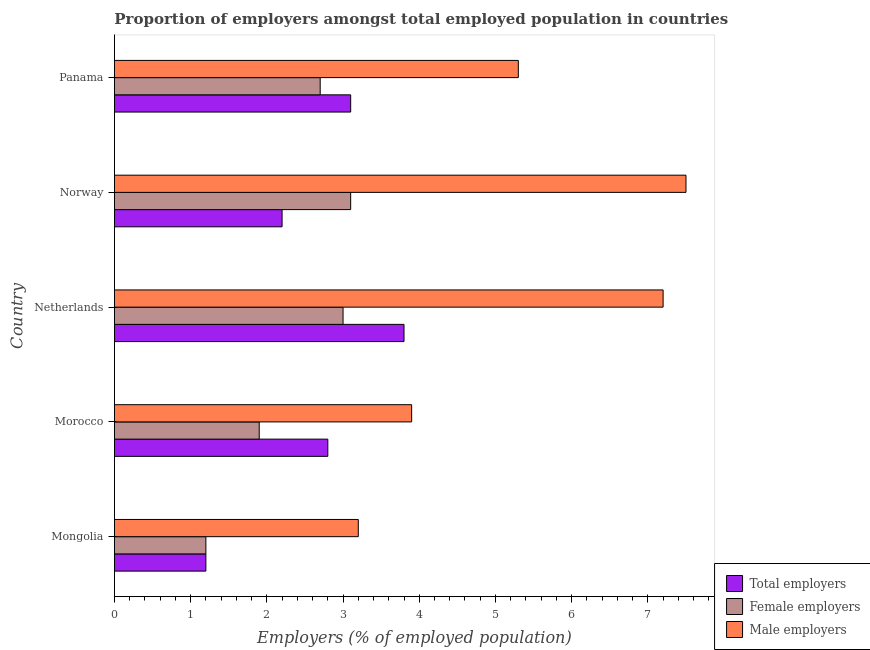How many different coloured bars are there?
Offer a terse response. 3. Are the number of bars on each tick of the Y-axis equal?
Provide a short and direct response. Yes. How many bars are there on the 2nd tick from the top?
Your response must be concise. 3. What is the label of the 5th group of bars from the top?
Your answer should be compact. Mongolia. In how many cases, is the number of bars for a given country not equal to the number of legend labels?
Ensure brevity in your answer.  0. Across all countries, what is the maximum percentage of male employers?
Offer a very short reply. 7.5. Across all countries, what is the minimum percentage of total employers?
Your answer should be very brief. 1.2. In which country was the percentage of male employers minimum?
Your response must be concise. Mongolia. What is the total percentage of female employers in the graph?
Keep it short and to the point. 11.9. What is the difference between the percentage of female employers in Mongolia and the percentage of total employers in Morocco?
Make the answer very short. -1.6. What is the average percentage of total employers per country?
Keep it short and to the point. 2.62. In how many countries, is the percentage of total employers greater than 7.2 %?
Your answer should be compact. 0. What is the ratio of the percentage of male employers in Mongolia to that in Morocco?
Your answer should be very brief. 0.82. In how many countries, is the percentage of male employers greater than the average percentage of male employers taken over all countries?
Offer a terse response. 2. What does the 2nd bar from the top in Panama represents?
Your response must be concise. Female employers. What does the 1st bar from the bottom in Netherlands represents?
Keep it short and to the point. Total employers. Is it the case that in every country, the sum of the percentage of total employers and percentage of female employers is greater than the percentage of male employers?
Provide a succinct answer. No. Are all the bars in the graph horizontal?
Provide a succinct answer. Yes. How many countries are there in the graph?
Offer a terse response. 5. Does the graph contain grids?
Offer a terse response. No. How many legend labels are there?
Make the answer very short. 3. What is the title of the graph?
Offer a terse response. Proportion of employers amongst total employed population in countries. Does "Secondary" appear as one of the legend labels in the graph?
Your response must be concise. No. What is the label or title of the X-axis?
Offer a very short reply. Employers (% of employed population). What is the Employers (% of employed population) in Total employers in Mongolia?
Your answer should be very brief. 1.2. What is the Employers (% of employed population) in Female employers in Mongolia?
Offer a very short reply. 1.2. What is the Employers (% of employed population) of Male employers in Mongolia?
Your answer should be compact. 3.2. What is the Employers (% of employed population) in Total employers in Morocco?
Ensure brevity in your answer.  2.8. What is the Employers (% of employed population) in Female employers in Morocco?
Your answer should be very brief. 1.9. What is the Employers (% of employed population) of Male employers in Morocco?
Provide a short and direct response. 3.9. What is the Employers (% of employed population) in Total employers in Netherlands?
Keep it short and to the point. 3.8. What is the Employers (% of employed population) in Female employers in Netherlands?
Keep it short and to the point. 3. What is the Employers (% of employed population) in Male employers in Netherlands?
Provide a short and direct response. 7.2. What is the Employers (% of employed population) in Total employers in Norway?
Ensure brevity in your answer.  2.2. What is the Employers (% of employed population) in Female employers in Norway?
Provide a short and direct response. 3.1. What is the Employers (% of employed population) in Male employers in Norway?
Your response must be concise. 7.5. What is the Employers (% of employed population) of Total employers in Panama?
Keep it short and to the point. 3.1. What is the Employers (% of employed population) in Female employers in Panama?
Your answer should be very brief. 2.7. What is the Employers (% of employed population) of Male employers in Panama?
Offer a terse response. 5.3. Across all countries, what is the maximum Employers (% of employed population) of Total employers?
Make the answer very short. 3.8. Across all countries, what is the maximum Employers (% of employed population) in Female employers?
Ensure brevity in your answer.  3.1. Across all countries, what is the minimum Employers (% of employed population) in Total employers?
Offer a very short reply. 1.2. Across all countries, what is the minimum Employers (% of employed population) in Female employers?
Give a very brief answer. 1.2. Across all countries, what is the minimum Employers (% of employed population) of Male employers?
Provide a succinct answer. 3.2. What is the total Employers (% of employed population) of Total employers in the graph?
Keep it short and to the point. 13.1. What is the total Employers (% of employed population) in Female employers in the graph?
Offer a terse response. 11.9. What is the total Employers (% of employed population) of Male employers in the graph?
Your answer should be compact. 27.1. What is the difference between the Employers (% of employed population) of Total employers in Mongolia and that in Morocco?
Your answer should be compact. -1.6. What is the difference between the Employers (% of employed population) in Total employers in Mongolia and that in Netherlands?
Your answer should be very brief. -2.6. What is the difference between the Employers (% of employed population) in Female employers in Mongolia and that in Netherlands?
Make the answer very short. -1.8. What is the difference between the Employers (% of employed population) of Male employers in Mongolia and that in Netherlands?
Offer a very short reply. -4. What is the difference between the Employers (% of employed population) in Total employers in Mongolia and that in Norway?
Offer a very short reply. -1. What is the difference between the Employers (% of employed population) in Male employers in Mongolia and that in Norway?
Your answer should be compact. -4.3. What is the difference between the Employers (% of employed population) of Male employers in Mongolia and that in Panama?
Give a very brief answer. -2.1. What is the difference between the Employers (% of employed population) of Total employers in Morocco and that in Netherlands?
Give a very brief answer. -1. What is the difference between the Employers (% of employed population) of Total employers in Morocco and that in Panama?
Your answer should be compact. -0.3. What is the difference between the Employers (% of employed population) in Female employers in Netherlands and that in Panama?
Your answer should be compact. 0.3. What is the difference between the Employers (% of employed population) of Male employers in Netherlands and that in Panama?
Give a very brief answer. 1.9. What is the difference between the Employers (% of employed population) of Total employers in Mongolia and the Employers (% of employed population) of Female employers in Morocco?
Your response must be concise. -0.7. What is the difference between the Employers (% of employed population) of Total employers in Mongolia and the Employers (% of employed population) of Male employers in Morocco?
Provide a short and direct response. -2.7. What is the difference between the Employers (% of employed population) in Female employers in Mongolia and the Employers (% of employed population) in Male employers in Morocco?
Your response must be concise. -2.7. What is the difference between the Employers (% of employed population) in Total employers in Mongolia and the Employers (% of employed population) in Female employers in Netherlands?
Offer a very short reply. -1.8. What is the difference between the Employers (% of employed population) in Total employers in Mongolia and the Employers (% of employed population) in Male employers in Netherlands?
Your answer should be compact. -6. What is the difference between the Employers (% of employed population) in Female employers in Mongolia and the Employers (% of employed population) in Male employers in Netherlands?
Provide a succinct answer. -6. What is the difference between the Employers (% of employed population) of Total employers in Mongolia and the Employers (% of employed population) of Male employers in Norway?
Ensure brevity in your answer.  -6.3. What is the difference between the Employers (% of employed population) of Total employers in Mongolia and the Employers (% of employed population) of Male employers in Panama?
Keep it short and to the point. -4.1. What is the difference between the Employers (% of employed population) in Female employers in Mongolia and the Employers (% of employed population) in Male employers in Panama?
Make the answer very short. -4.1. What is the difference between the Employers (% of employed population) in Total employers in Morocco and the Employers (% of employed population) in Female employers in Netherlands?
Keep it short and to the point. -0.2. What is the difference between the Employers (% of employed population) of Female employers in Morocco and the Employers (% of employed population) of Male employers in Netherlands?
Keep it short and to the point. -5.3. What is the difference between the Employers (% of employed population) in Total employers in Morocco and the Employers (% of employed population) in Male employers in Norway?
Offer a terse response. -4.7. What is the difference between the Employers (% of employed population) in Female employers in Morocco and the Employers (% of employed population) in Male employers in Norway?
Make the answer very short. -5.6. What is the difference between the Employers (% of employed population) of Total employers in Morocco and the Employers (% of employed population) of Female employers in Panama?
Offer a very short reply. 0.1. What is the difference between the Employers (% of employed population) in Total employers in Morocco and the Employers (% of employed population) in Male employers in Panama?
Give a very brief answer. -2.5. What is the difference between the Employers (% of employed population) of Female employers in Morocco and the Employers (% of employed population) of Male employers in Panama?
Your answer should be very brief. -3.4. What is the difference between the Employers (% of employed population) in Total employers in Netherlands and the Employers (% of employed population) in Male employers in Norway?
Make the answer very short. -3.7. What is the difference between the Employers (% of employed population) in Female employers in Netherlands and the Employers (% of employed population) in Male employers in Norway?
Provide a succinct answer. -4.5. What is the difference between the Employers (% of employed population) in Total employers in Netherlands and the Employers (% of employed population) in Female employers in Panama?
Provide a succinct answer. 1.1. What is the difference between the Employers (% of employed population) in Total employers in Netherlands and the Employers (% of employed population) in Male employers in Panama?
Provide a short and direct response. -1.5. What is the difference between the Employers (% of employed population) of Total employers in Norway and the Employers (% of employed population) of Female employers in Panama?
Make the answer very short. -0.5. What is the difference between the Employers (% of employed population) of Total employers in Norway and the Employers (% of employed population) of Male employers in Panama?
Offer a very short reply. -3.1. What is the difference between the Employers (% of employed population) in Female employers in Norway and the Employers (% of employed population) in Male employers in Panama?
Keep it short and to the point. -2.2. What is the average Employers (% of employed population) in Total employers per country?
Your answer should be very brief. 2.62. What is the average Employers (% of employed population) in Female employers per country?
Your answer should be compact. 2.38. What is the average Employers (% of employed population) of Male employers per country?
Make the answer very short. 5.42. What is the difference between the Employers (% of employed population) of Total employers and Employers (% of employed population) of Male employers in Mongolia?
Make the answer very short. -2. What is the difference between the Employers (% of employed population) in Total employers and Employers (% of employed population) in Male employers in Morocco?
Your answer should be very brief. -1.1. What is the difference between the Employers (% of employed population) of Female employers and Employers (% of employed population) of Male employers in Morocco?
Ensure brevity in your answer.  -2. What is the difference between the Employers (% of employed population) of Total employers and Employers (% of employed population) of Female employers in Netherlands?
Ensure brevity in your answer.  0.8. What is the difference between the Employers (% of employed population) of Total employers and Employers (% of employed population) of Male employers in Netherlands?
Offer a very short reply. -3.4. What is the difference between the Employers (% of employed population) of Female employers and Employers (% of employed population) of Male employers in Netherlands?
Provide a succinct answer. -4.2. What is the difference between the Employers (% of employed population) of Total employers and Employers (% of employed population) of Female employers in Norway?
Offer a very short reply. -0.9. What is the difference between the Employers (% of employed population) in Total employers and Employers (% of employed population) in Female employers in Panama?
Make the answer very short. 0.4. What is the difference between the Employers (% of employed population) of Total employers and Employers (% of employed population) of Male employers in Panama?
Offer a very short reply. -2.2. What is the difference between the Employers (% of employed population) in Female employers and Employers (% of employed population) in Male employers in Panama?
Your answer should be very brief. -2.6. What is the ratio of the Employers (% of employed population) in Total employers in Mongolia to that in Morocco?
Give a very brief answer. 0.43. What is the ratio of the Employers (% of employed population) in Female employers in Mongolia to that in Morocco?
Make the answer very short. 0.63. What is the ratio of the Employers (% of employed population) in Male employers in Mongolia to that in Morocco?
Offer a very short reply. 0.82. What is the ratio of the Employers (% of employed population) of Total employers in Mongolia to that in Netherlands?
Provide a short and direct response. 0.32. What is the ratio of the Employers (% of employed population) of Male employers in Mongolia to that in Netherlands?
Your answer should be compact. 0.44. What is the ratio of the Employers (% of employed population) of Total employers in Mongolia to that in Norway?
Provide a short and direct response. 0.55. What is the ratio of the Employers (% of employed population) in Female employers in Mongolia to that in Norway?
Provide a short and direct response. 0.39. What is the ratio of the Employers (% of employed population) in Male employers in Mongolia to that in Norway?
Your response must be concise. 0.43. What is the ratio of the Employers (% of employed population) of Total employers in Mongolia to that in Panama?
Make the answer very short. 0.39. What is the ratio of the Employers (% of employed population) of Female employers in Mongolia to that in Panama?
Provide a short and direct response. 0.44. What is the ratio of the Employers (% of employed population) in Male employers in Mongolia to that in Panama?
Your response must be concise. 0.6. What is the ratio of the Employers (% of employed population) in Total employers in Morocco to that in Netherlands?
Give a very brief answer. 0.74. What is the ratio of the Employers (% of employed population) of Female employers in Morocco to that in Netherlands?
Your answer should be compact. 0.63. What is the ratio of the Employers (% of employed population) of Male employers in Morocco to that in Netherlands?
Ensure brevity in your answer.  0.54. What is the ratio of the Employers (% of employed population) in Total employers in Morocco to that in Norway?
Your response must be concise. 1.27. What is the ratio of the Employers (% of employed population) of Female employers in Morocco to that in Norway?
Your response must be concise. 0.61. What is the ratio of the Employers (% of employed population) in Male employers in Morocco to that in Norway?
Provide a short and direct response. 0.52. What is the ratio of the Employers (% of employed population) of Total employers in Morocco to that in Panama?
Your answer should be very brief. 0.9. What is the ratio of the Employers (% of employed population) of Female employers in Morocco to that in Panama?
Offer a terse response. 0.7. What is the ratio of the Employers (% of employed population) of Male employers in Morocco to that in Panama?
Provide a succinct answer. 0.74. What is the ratio of the Employers (% of employed population) of Total employers in Netherlands to that in Norway?
Give a very brief answer. 1.73. What is the ratio of the Employers (% of employed population) in Female employers in Netherlands to that in Norway?
Offer a very short reply. 0.97. What is the ratio of the Employers (% of employed population) of Total employers in Netherlands to that in Panama?
Give a very brief answer. 1.23. What is the ratio of the Employers (% of employed population) of Male employers in Netherlands to that in Panama?
Ensure brevity in your answer.  1.36. What is the ratio of the Employers (% of employed population) in Total employers in Norway to that in Panama?
Keep it short and to the point. 0.71. What is the ratio of the Employers (% of employed population) in Female employers in Norway to that in Panama?
Keep it short and to the point. 1.15. What is the ratio of the Employers (% of employed population) of Male employers in Norway to that in Panama?
Provide a succinct answer. 1.42. What is the difference between the highest and the second highest Employers (% of employed population) of Total employers?
Offer a very short reply. 0.7. What is the difference between the highest and the second highest Employers (% of employed population) of Female employers?
Provide a short and direct response. 0.1. What is the difference between the highest and the second highest Employers (% of employed population) in Male employers?
Offer a very short reply. 0.3. 